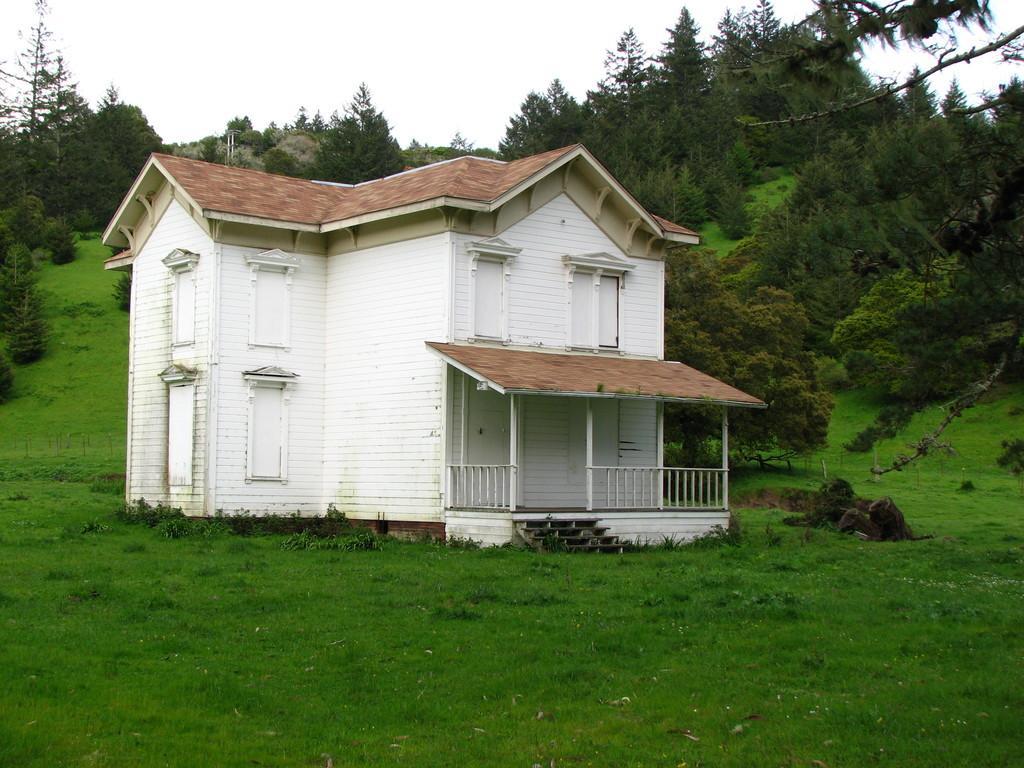Can you describe this image briefly? In this picture, there is a house with roof tiles which is in center. At the bottom, there is grass. In the background, there are trees and sky. 